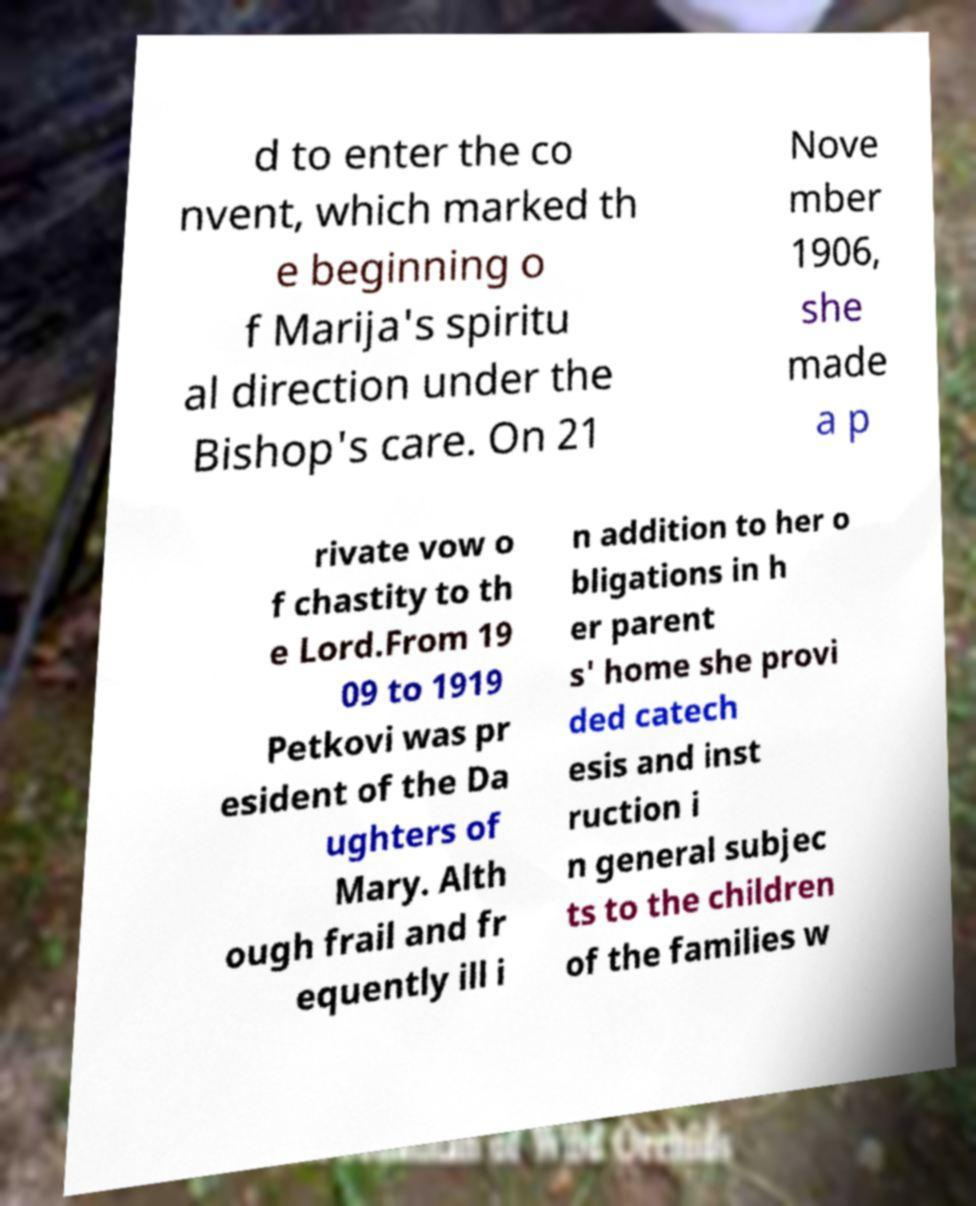Please read and relay the text visible in this image. What does it say? d to enter the co nvent, which marked th e beginning o f Marija's spiritu al direction under the Bishop's care. On 21 Nove mber 1906, she made a p rivate vow o f chastity to th e Lord.From 19 09 to 1919 Petkovi was pr esident of the Da ughters of Mary. Alth ough frail and fr equently ill i n addition to her o bligations in h er parent s' home she provi ded catech esis and inst ruction i n general subjec ts to the children of the families w 